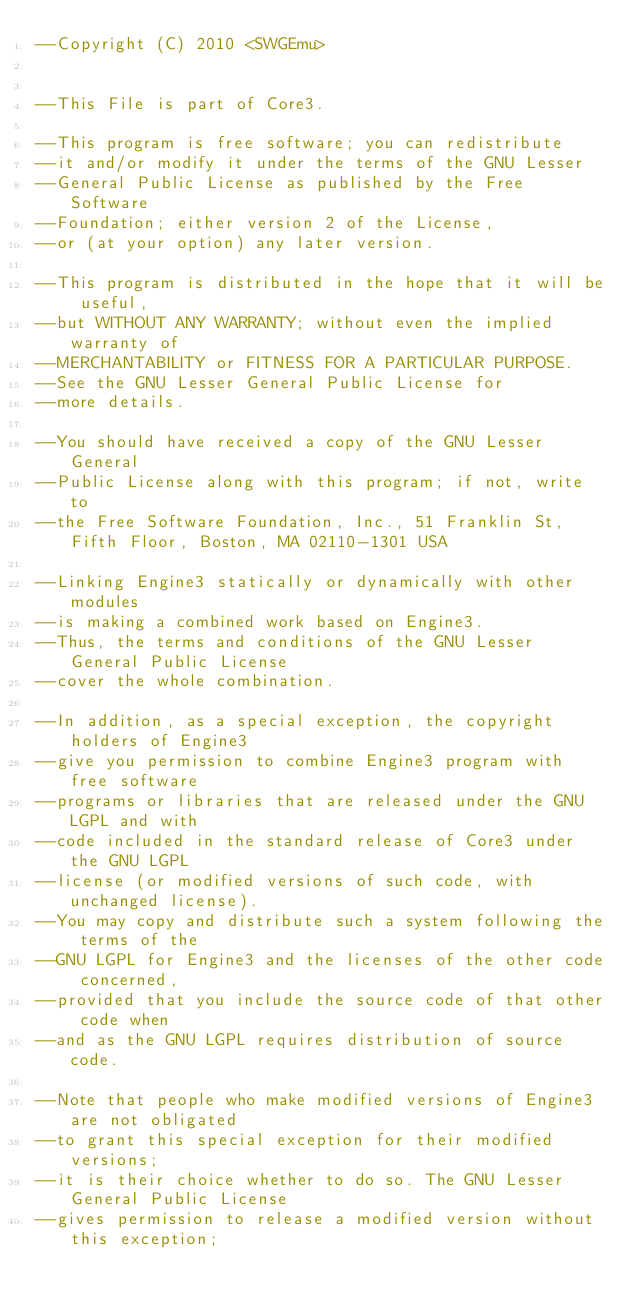<code> <loc_0><loc_0><loc_500><loc_500><_Lua_>--Copyright (C) 2010 <SWGEmu>


--This File is part of Core3.

--This program is free software; you can redistribute 
--it and/or modify it under the terms of the GNU Lesser 
--General Public License as published by the Free Software
--Foundation; either version 2 of the License, 
--or (at your option) any later version.

--This program is distributed in the hope that it will be useful, 
--but WITHOUT ANY WARRANTY; without even the implied warranty of 
--MERCHANTABILITY or FITNESS FOR A PARTICULAR PURPOSE. 
--See the GNU Lesser General Public License for
--more details.

--You should have received a copy of the GNU Lesser General 
--Public License along with this program; if not, write to
--the Free Software Foundation, Inc., 51 Franklin St, Fifth Floor, Boston, MA 02110-1301 USA

--Linking Engine3 statically or dynamically with other modules 
--is making a combined work based on Engine3. 
--Thus, the terms and conditions of the GNU Lesser General Public License 
--cover the whole combination.

--In addition, as a special exception, the copyright holders of Engine3 
--give you permission to combine Engine3 program with free software 
--programs or libraries that are released under the GNU LGPL and with 
--code included in the standard release of Core3 under the GNU LGPL 
--license (or modified versions of such code, with unchanged license). 
--You may copy and distribute such a system following the terms of the 
--GNU LGPL for Engine3 and the licenses of the other code concerned, 
--provided that you include the source code of that other code when 
--and as the GNU LGPL requires distribution of source code.

--Note that people who make modified versions of Engine3 are not obligated 
--to grant this special exception for their modified versions; 
--it is their choice whether to do so. The GNU Lesser General Public License 
--gives permission to release a modified version without this exception; </code> 